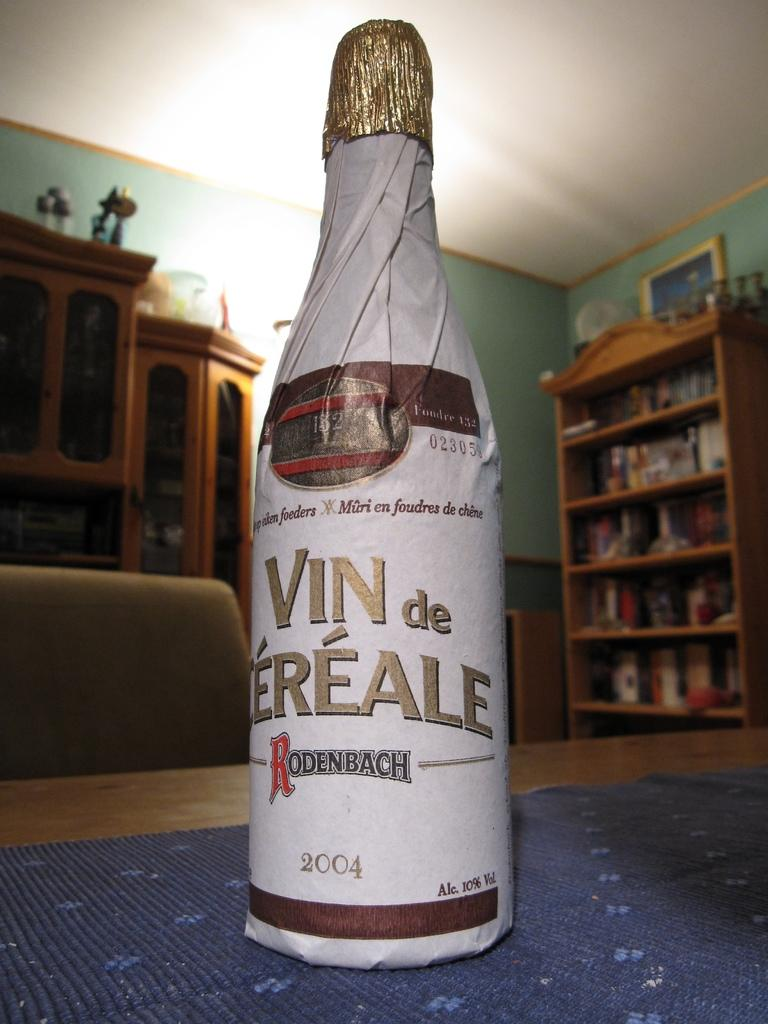<image>
Create a compact narrative representing the image presented. A bottle of wine from 2004 is wrapped in white paper. 